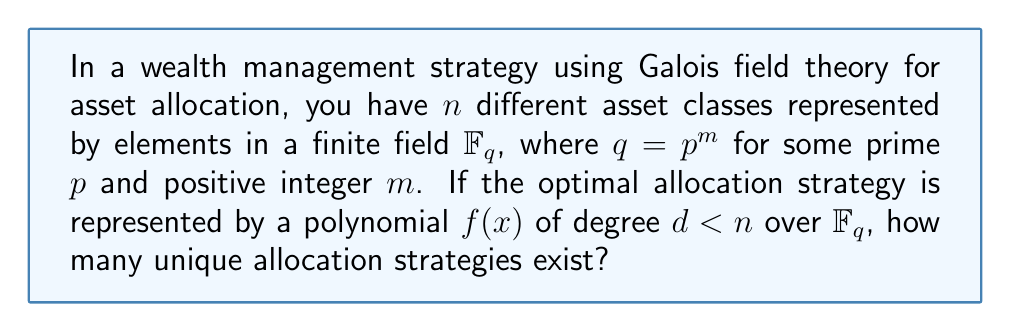Can you solve this math problem? Let's approach this step-by-step:

1) In Galois field theory, polynomials over a finite field $\mathbb{F}_q$ play a crucial role. Here, we're using them to represent allocation strategies.

2) The number of elements in $\mathbb{F}_q$ is $q = p^m$, where $p$ is prime and $m$ is a positive integer.

3) We're looking for polynomials of degree less than $n$ over $\mathbb{F}_q$. This means the polynomials will be of the form:

   $$f(x) = a_0 + a_1x + a_2x^2 + ... + a_{d}x^d$$

   where $d < n$ and each $a_i \in \mathbb{F}_q$.

4) For each coefficient $a_i$, we have $q$ choices (any element from $\mathbb{F}_q$).

5) The number of coefficients is $d+1$ (from $a_0$ to $a_d$).

6) Since $d$ can range from 0 to $n-1$, we need to sum up the number of possibilities for each degree:

   $$\sum_{d=0}^{n-1} q^{d+1}$$

7) This is a geometric series with $n$ terms, first term $a = q$, and common ratio $r = q$. The sum of such a series is given by:

   $$S_n = a\frac{1-r^n}{1-r} = q\frac{1-q^n}{1-q}$$

8) Substituting and simplifying:

   $$q\frac{1-q^n}{1-q} = \frac{q-q^{n+1}}{1-q} = \frac{q^{n+1}-q}{q-1}$$

Therefore, the number of unique allocation strategies is $\frac{q^{n+1}-q}{q-1}$.
Answer: $\frac{q^{n+1}-q}{q-1}$ 